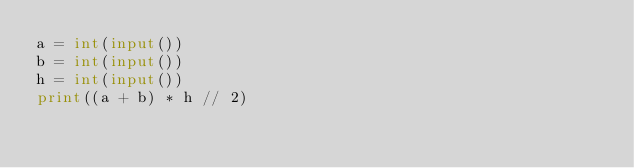<code> <loc_0><loc_0><loc_500><loc_500><_Python_>a = int(input())
b = int(input())
h = int(input())
print((a + b) * h // 2)</code> 